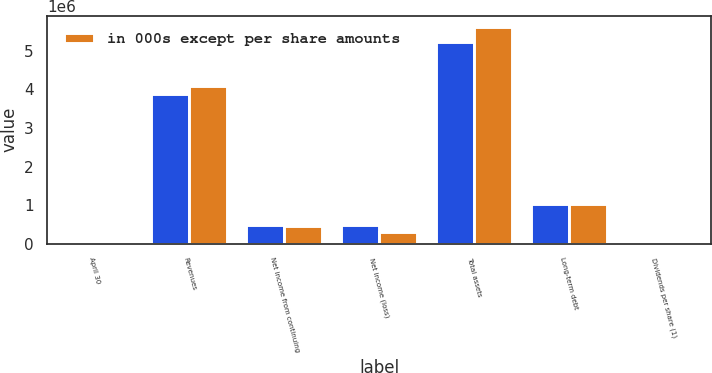Convert chart to OTSL. <chart><loc_0><loc_0><loc_500><loc_500><stacked_bar_chart><ecel><fcel>April 30<fcel>Revenues<fcel>Net income from continuing<fcel>Net income (loss)<fcel>Total assets<fcel>Long-term debt<fcel>Dividends per share (1)<nl><fcel>nan<fcel>2010<fcel>3.87433e+06<fcel>488946<fcel>479242<fcel>5.23432e+06<fcel>1.03514e+06<fcel>0.75<nl><fcel>in 000s except per share amounts<fcel>2008<fcel>4.08663e+06<fcel>445947<fcel>308647<fcel>5.62342e+06<fcel>1.03178e+06<fcel>0.56<nl></chart> 